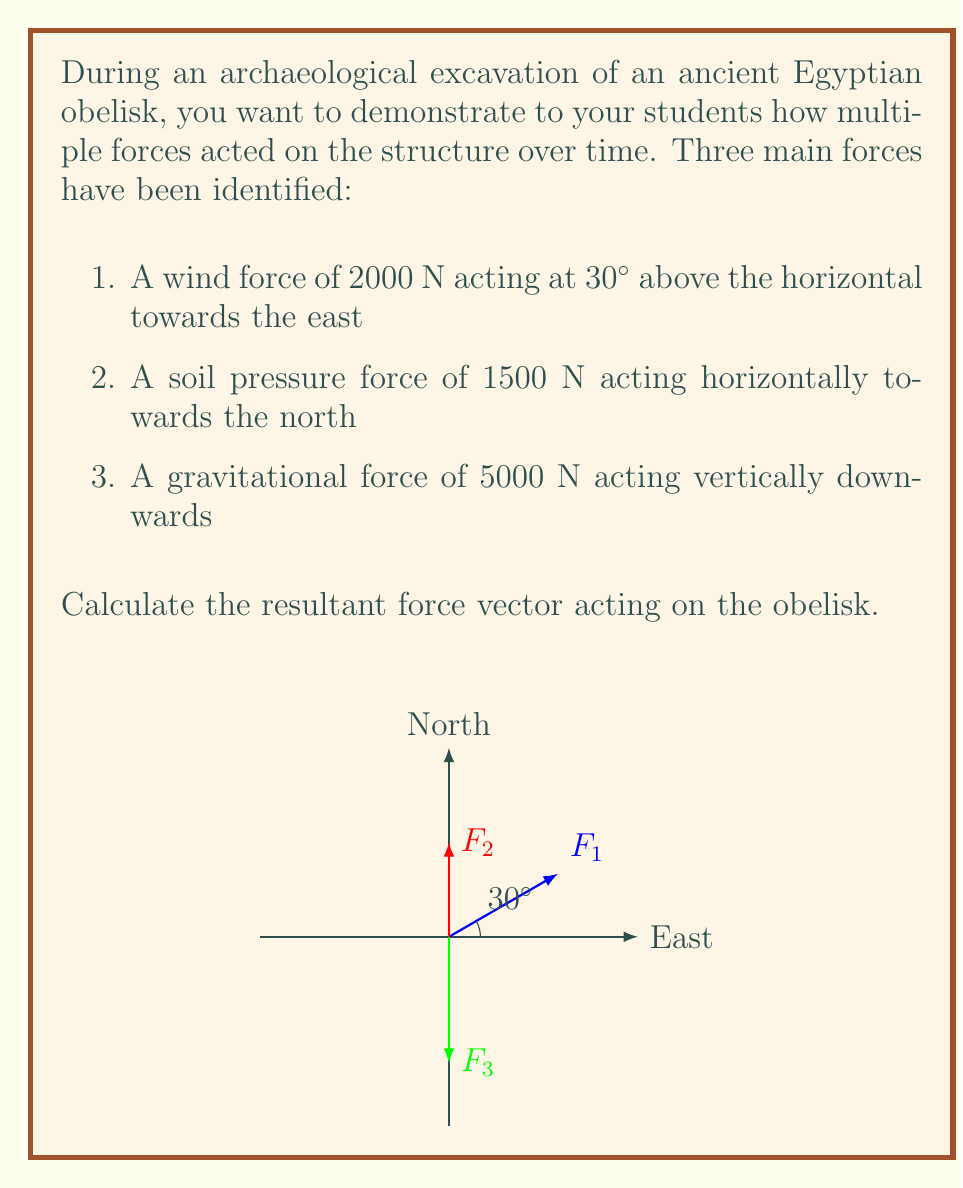Could you help me with this problem? To find the resultant force vector, we need to add the component vectors of each force. Let's break this down step-by-step:

1) First, let's resolve each force into its x, y, and z components:

   $F_1$ (wind force):
   $F_{1x} = 2000 \cos 30° = 2000 \cdot \frac{\sqrt{3}}{2} = 1732$ N (East)
   $F_{1y} = 0$ N (North-South)
   $F_{1z} = 2000 \sin 30° = 2000 \cdot \frac{1}{2} = 1000$ N (Up)

   $F_2$ (soil pressure):
   $F_{2x} = 0$ N (East-West)
   $F_{2y} = 1500$ N (North)
   $F_{2z} = 0$ N (Up-Down)

   $F_3$ (gravity):
   $F_{3x} = 0$ N (East-West)
   $F_{3y} = 0$ N (North-South)
   $F_{3z} = -5000$ N (Down)

2) Now, we sum the components in each direction:

   $\sum F_x = 1732$ N
   $\sum F_y = 1500$ N
   $\sum F_z = 1000 - 5000 = -4000$ N

3) The resultant force vector $\vec{R}$ is:

   $$\vec{R} = 1732\hat{i} + 1500\hat{j} - 4000\hat{k}$$

4) To find the magnitude of the resultant force:

   $$|\vec{R}| = \sqrt{1732^2 + 1500^2 + (-4000)^2} = 4628.7 \text{ N}$$

5) To find the direction, we can calculate the angles with each axis:

   $\theta_x = \cos^{-1}(\frac{1732}{4628.7}) = 68.1°$
   $\theta_y = \cos^{-1}(\frac{1500}{4628.7}) = 70.5°$
   $\theta_z = \cos^{-1}(\frac{|-4000|}{4628.7}) = 30.1°$

Thus, the resultant force has a magnitude of 4628.7 N and makes angles of 68.1°, 70.5°, and 30.1° with the positive x, y, and z axes respectively.
Answer: $\vec{R} = 1732\hat{i} + 1500\hat{j} - 4000\hat{k}$ N, $|\vec{R}| = 4628.7$ N 